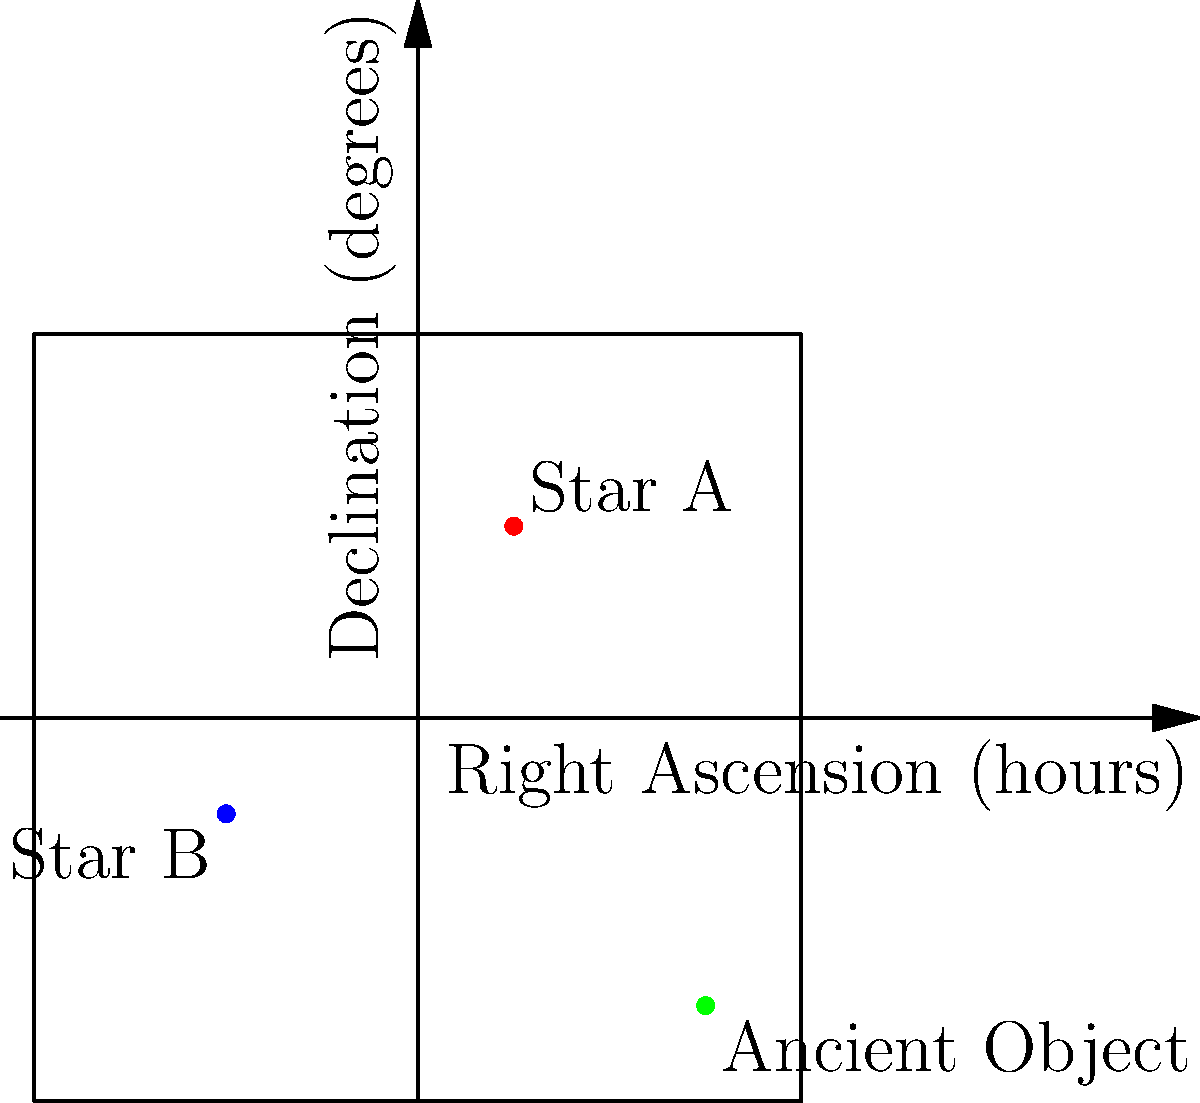As an antiques collector, you've discovered an ancient star map with an unusual coordinate system. The map shows three celestial objects: Star A (RA: 6h, Dec: +30°), Star B (RA: 2h, Dec: -15°), and an unidentified ancient object (RA: 18h, Dec: -45°). Given that Stars A and B are known to be 100 and 150 light-years away respectively, and the ancient object's position forms an isosceles triangle with these stars, estimate the age of the ancient object in years. Assume light travels at $3 \times 10^8$ m/s. To estimate the age of the ancient object, we'll follow these steps:

1. Calculate the angular distances between the objects:
   - Star A to Star B: $\Delta RA = 4h = 60°$, $\Delta Dec = 45°$
   - Star A to Ancient Object: $\Delta RA = 12h = 180°$, $\Delta Dec = 75°$
   - Star B to Ancient Object: $\Delta RA = 16h = 240°$, $\Delta Dec = 30°$

2. Use the spherical law of cosines to find the angular separations:
   $\cos(\theta) = \sin(Dec_1)\sin(Dec_2) + \cos(Dec_1)\cos(Dec_2)\cos(\Delta RA)$

   - A to B: $\theta_{AB} \approx 71.565°$
   - A to Ancient Object: $\theta_{AO} \approx 150.888°$
   - B to Ancient Object: $\theta_{BO} \approx 150.888°$

3. The triangle is isosceles with $\theta_{AO} = \theta_{BO}$, so the ancient object is equidistant from A and B.

4. Calculate the distance to the ancient object using the cosine rule:
   $d_{AO}^2 = d_A^2 + d_B^2 - 2d_Ad_B\cos(\theta_{AB})$

   $d_{AO} = \sqrt{100^2 + 150^2 - 2(100)(150)\cos(71.565°)} \approx 182.574$ light-years

5. The age of the ancient object is the time it took light to travel this distance:
   $Age = \frac{Distance}{Speed of light} = \frac{182.574 \text{ light-years}}{1 \text{ light-year/year}} \approx 182.574$ years
Answer: 183 years 